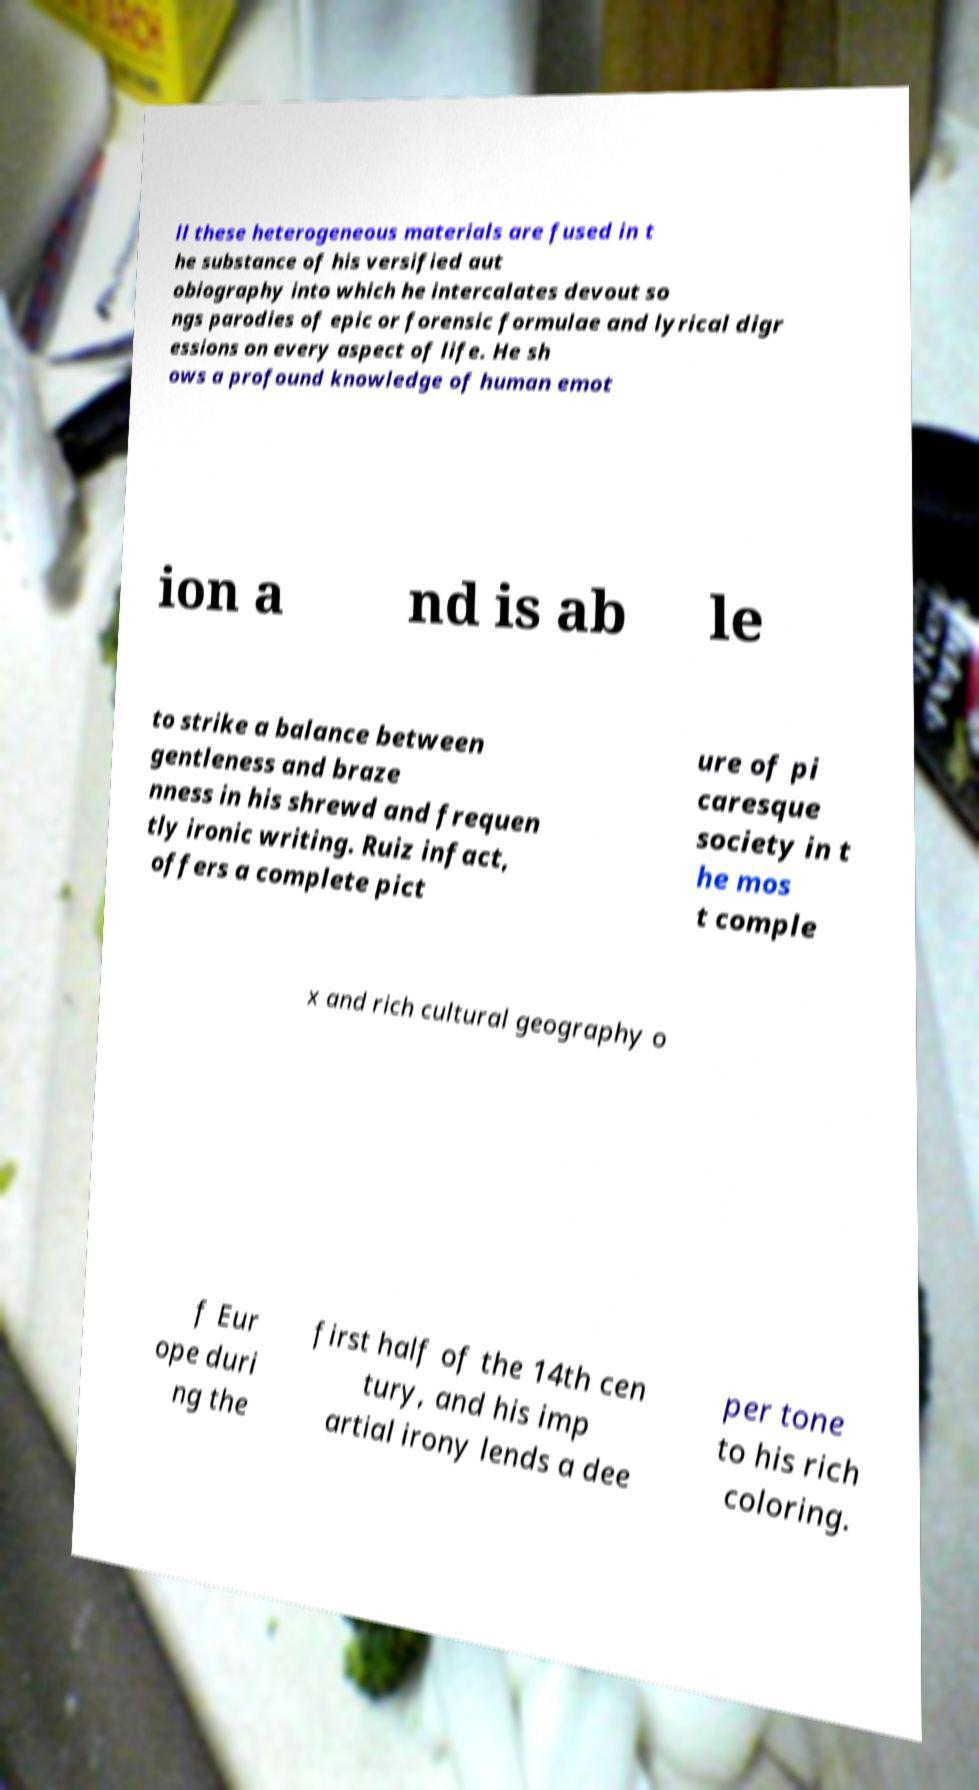Could you assist in decoding the text presented in this image and type it out clearly? ll these heterogeneous materials are fused in t he substance of his versified aut obiography into which he intercalates devout so ngs parodies of epic or forensic formulae and lyrical digr essions on every aspect of life. He sh ows a profound knowledge of human emot ion a nd is ab le to strike a balance between gentleness and braze nness in his shrewd and frequen tly ironic writing. Ruiz infact, offers a complete pict ure of pi caresque society in t he mos t comple x and rich cultural geography o f Eur ope duri ng the first half of the 14th cen tury, and his imp artial irony lends a dee per tone to his rich coloring. 